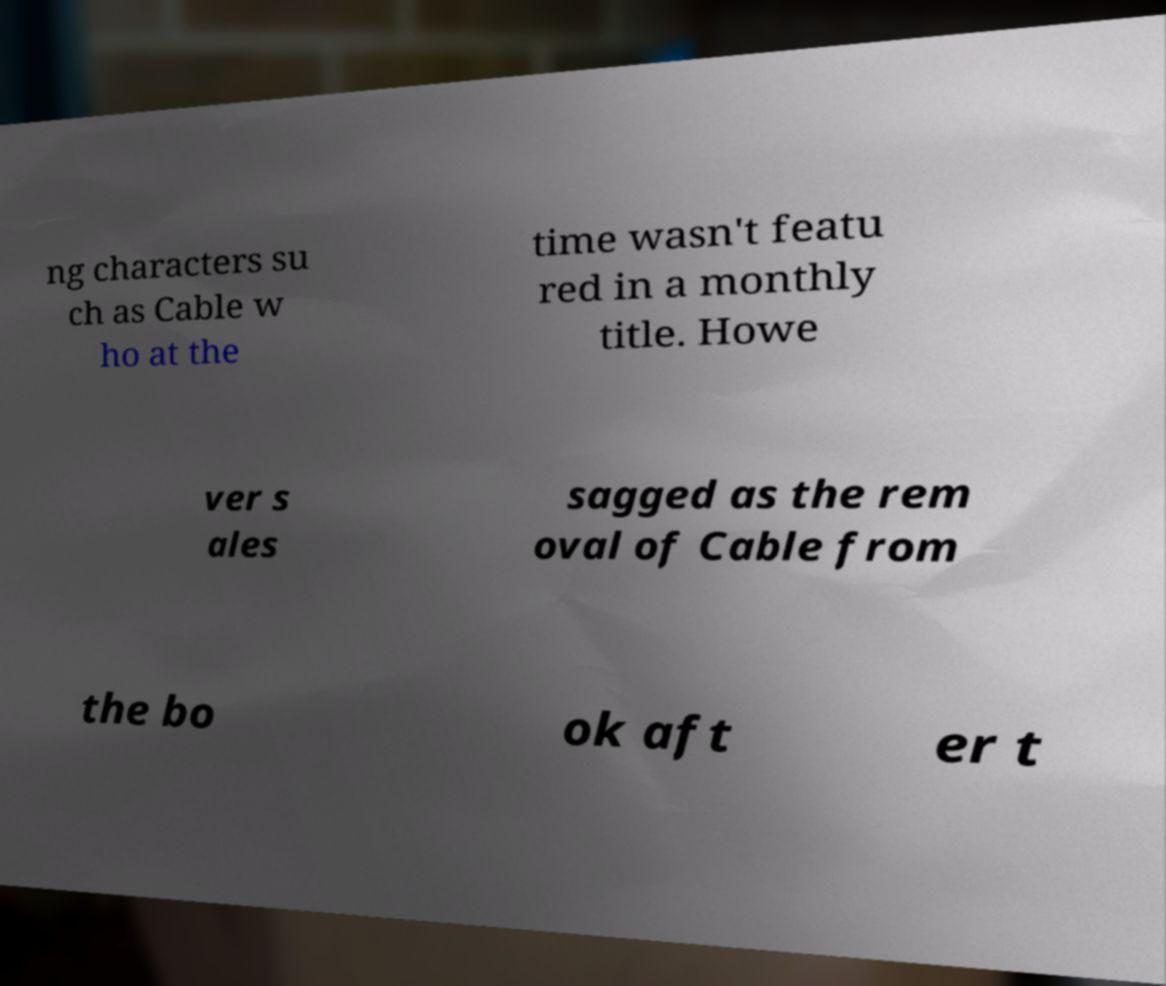Please identify and transcribe the text found in this image. ng characters su ch as Cable w ho at the time wasn't featu red in a monthly title. Howe ver s ales sagged as the rem oval of Cable from the bo ok aft er t 